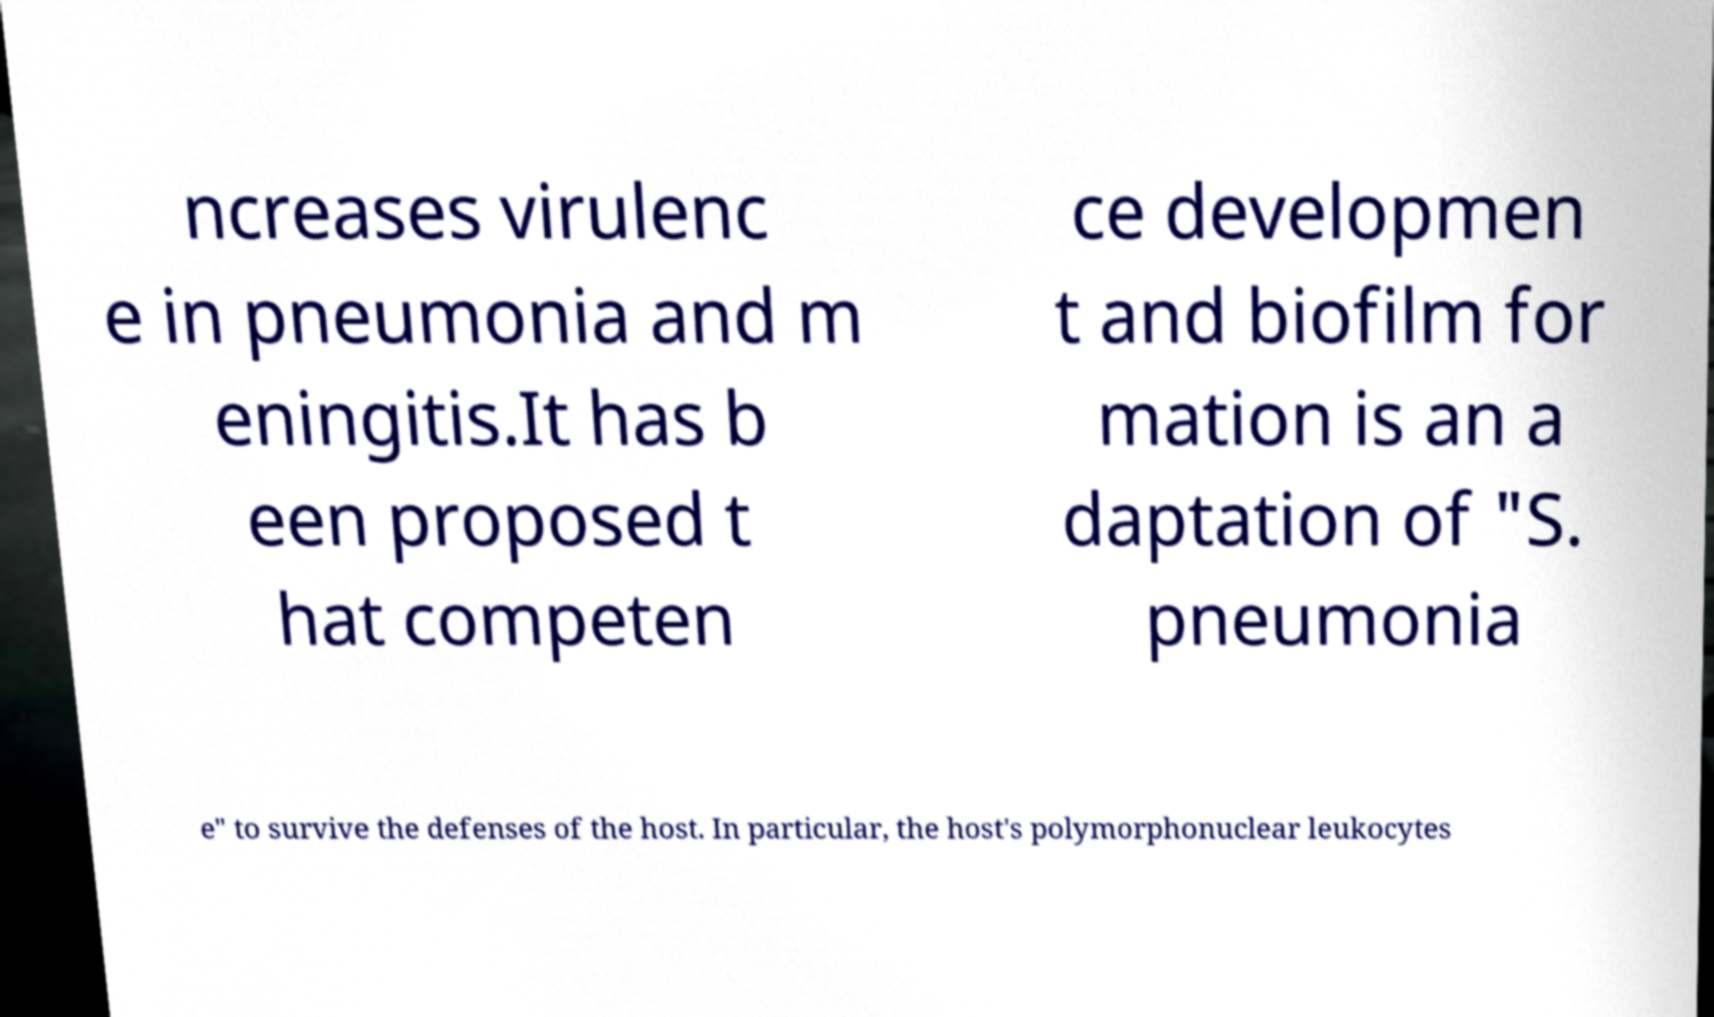I need the written content from this picture converted into text. Can you do that? ncreases virulenc e in pneumonia and m eningitis.It has b een proposed t hat competen ce developmen t and biofilm for mation is an a daptation of "S. pneumonia e" to survive the defenses of the host. In particular, the host's polymorphonuclear leukocytes 